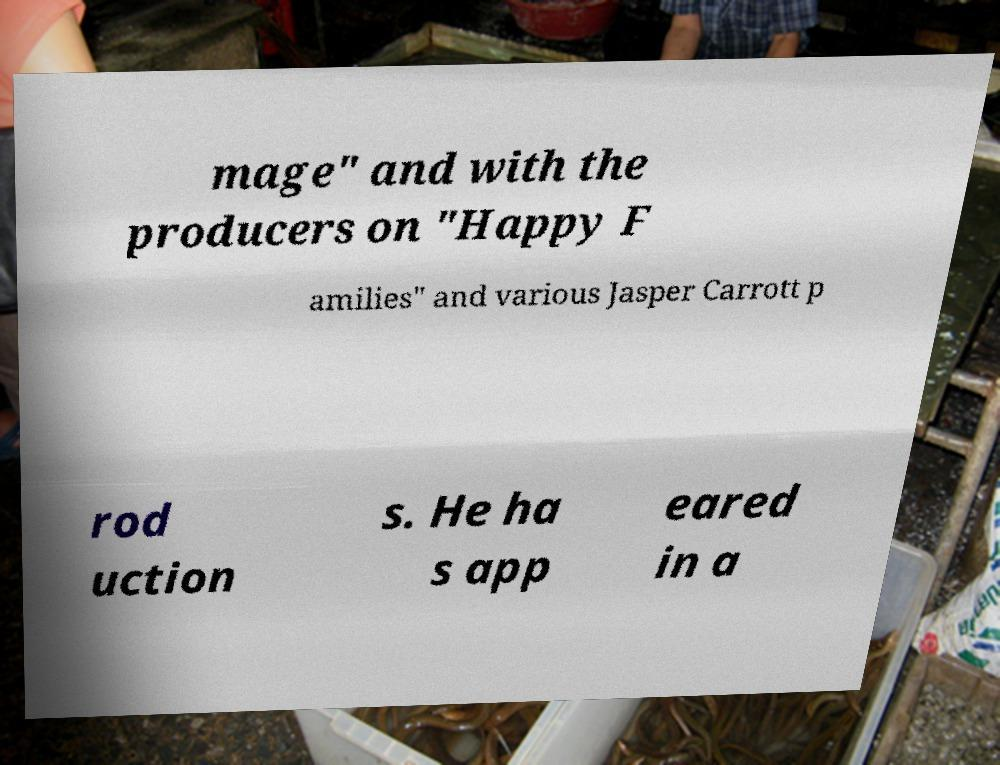Please read and relay the text visible in this image. What does it say? mage" and with the producers on "Happy F amilies" and various Jasper Carrott p rod uction s. He ha s app eared in a 